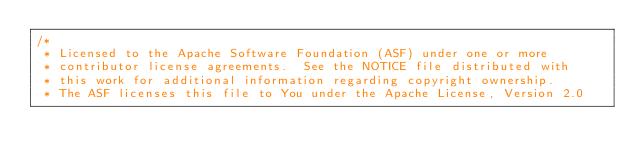Convert code to text. <code><loc_0><loc_0><loc_500><loc_500><_Java_>/*
 * Licensed to the Apache Software Foundation (ASF) under one or more
 * contributor license agreements.  See the NOTICE file distributed with
 * this work for additional information regarding copyright ownership.
 * The ASF licenses this file to You under the Apache License, Version 2.0</code> 